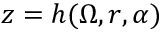Convert formula to latex. <formula><loc_0><loc_0><loc_500><loc_500>z = h ( \Omega , r , \alpha )</formula> 